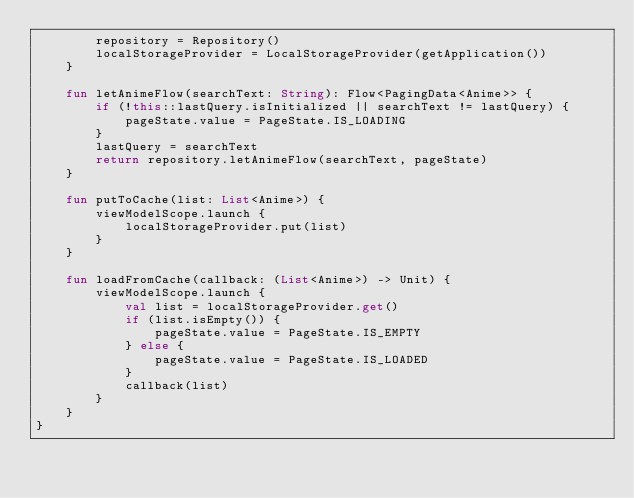<code> <loc_0><loc_0><loc_500><loc_500><_Kotlin_>        repository = Repository()
        localStorageProvider = LocalStorageProvider(getApplication())
    }

    fun letAnimeFlow(searchText: String): Flow<PagingData<Anime>> {
        if (!this::lastQuery.isInitialized || searchText != lastQuery) {
            pageState.value = PageState.IS_LOADING
        }
        lastQuery = searchText
        return repository.letAnimeFlow(searchText, pageState)
    }

    fun putToCache(list: List<Anime>) {
        viewModelScope.launch {
            localStorageProvider.put(list)
        }
    }

    fun loadFromCache(callback: (List<Anime>) -> Unit) {
        viewModelScope.launch {
            val list = localStorageProvider.get()
            if (list.isEmpty()) {
                pageState.value = PageState.IS_EMPTY
            } else {
                pageState.value = PageState.IS_LOADED
            }
            callback(list)
        }
    }
}
</code> 